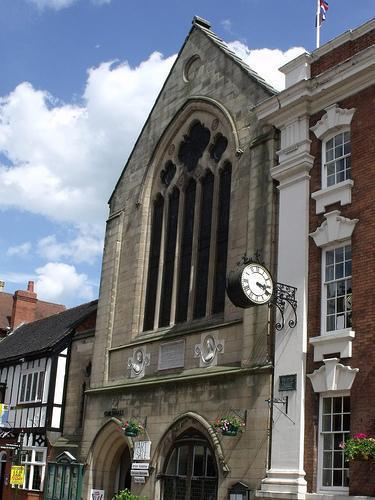How many clocks are in the photo?
Give a very brief answer. 1. How many potted plants are hanging from the buildings?
Give a very brief answer. 3. How many buildings are visible in the photo?
Give a very brief answer. 4. How many windows are visible on the front of the red brick building on the right of the photo?
Give a very brief answer. 3. 